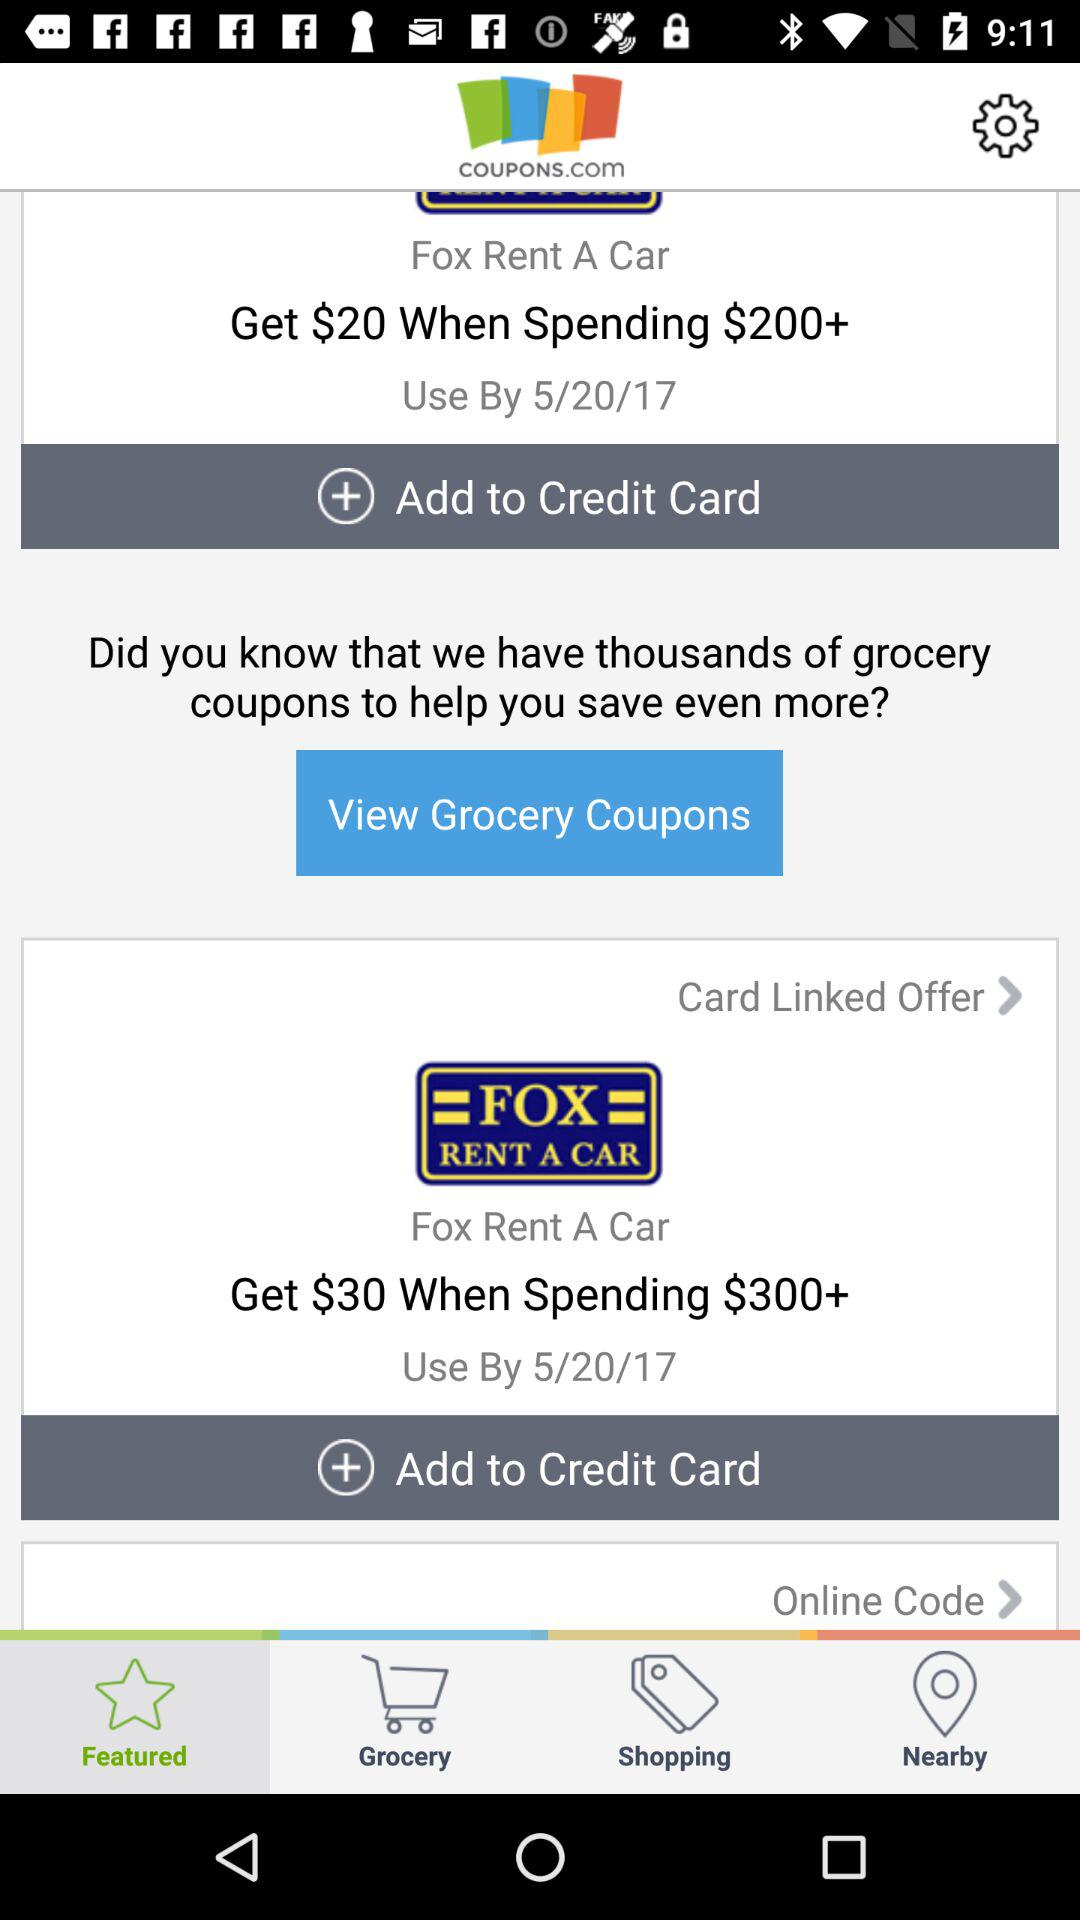What is the given date? The given date is 5/20/17. 